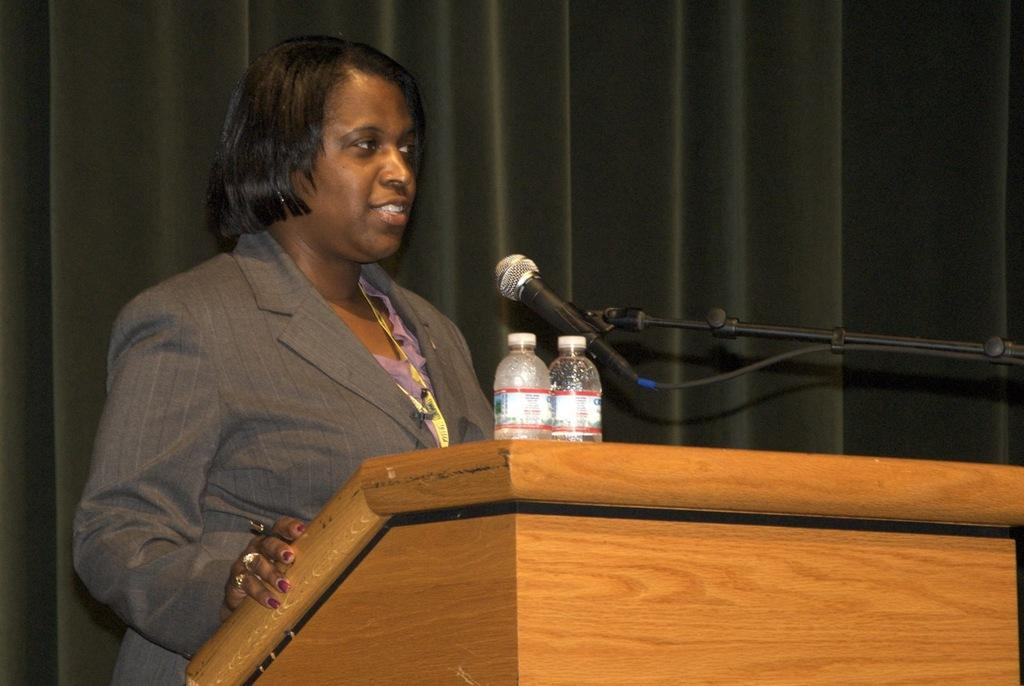What is the main subject of the image? There is a person in the image. What is the person wearing? The person is wearing a blazer. Where is the person standing in relation to the podium? The person is standing near a podium. What items are on the podium? There are two bottles and a microphone stand on the podium. What can be seen in the background of the image? There are black color curtains in the background. What type of church can be seen in the background of the image? There is no church visible in the image; the background features black color curtains. What kind of curve is the person making with their body in the image? The image does not show the person making any curve with their body; they are standing near a podium. 